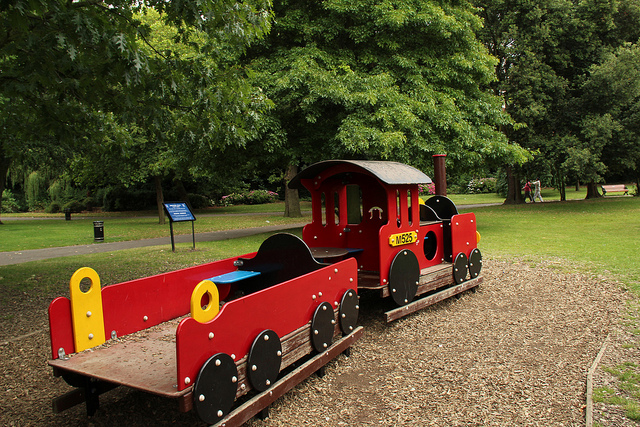Please transcribe the text information in this image. M525 